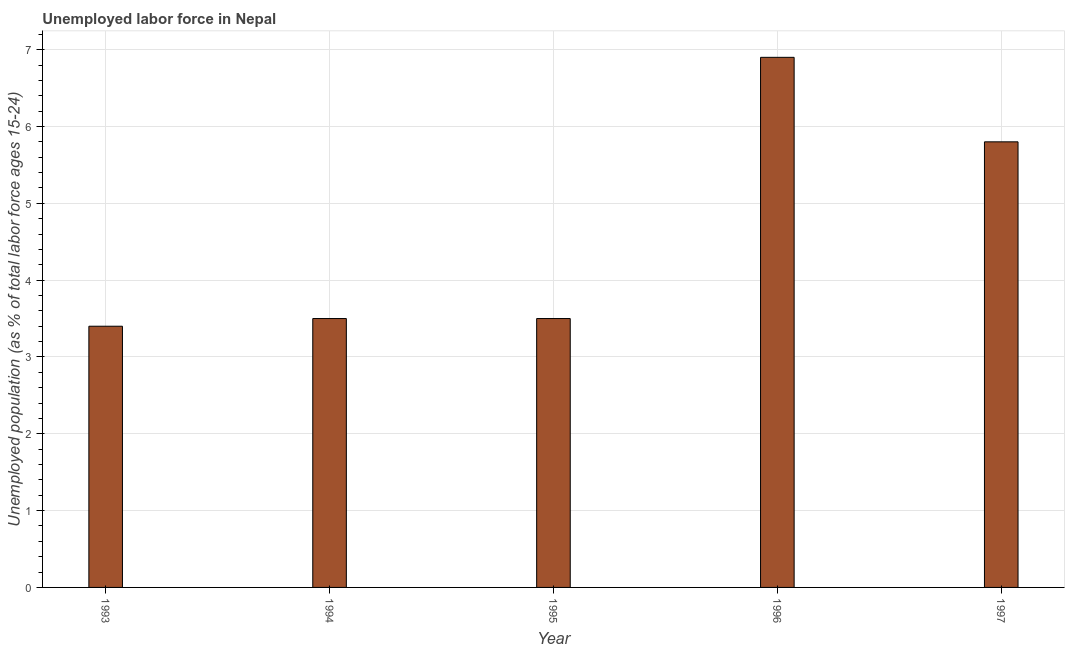Does the graph contain any zero values?
Keep it short and to the point. No. What is the title of the graph?
Your answer should be compact. Unemployed labor force in Nepal. What is the label or title of the X-axis?
Your response must be concise. Year. What is the label or title of the Y-axis?
Your response must be concise. Unemployed population (as % of total labor force ages 15-24). Across all years, what is the maximum total unemployed youth population?
Keep it short and to the point. 6.9. Across all years, what is the minimum total unemployed youth population?
Offer a terse response. 3.4. What is the sum of the total unemployed youth population?
Provide a short and direct response. 23.1. What is the difference between the total unemployed youth population in 1995 and 1996?
Your response must be concise. -3.4. What is the average total unemployed youth population per year?
Your answer should be compact. 4.62. What is the median total unemployed youth population?
Your response must be concise. 3.5. In how many years, is the total unemployed youth population greater than 6.6 %?
Provide a succinct answer. 1. Do a majority of the years between 1993 and 1995 (inclusive) have total unemployed youth population greater than 5.6 %?
Your answer should be compact. No. What is the ratio of the total unemployed youth population in 1993 to that in 1995?
Your response must be concise. 0.97. Is the total unemployed youth population in 1993 less than that in 1995?
Provide a succinct answer. Yes. Is the difference between the total unemployed youth population in 1995 and 1996 greater than the difference between any two years?
Give a very brief answer. No. How many bars are there?
Offer a terse response. 5. How many years are there in the graph?
Offer a very short reply. 5. What is the difference between two consecutive major ticks on the Y-axis?
Your answer should be very brief. 1. Are the values on the major ticks of Y-axis written in scientific E-notation?
Offer a very short reply. No. What is the Unemployed population (as % of total labor force ages 15-24) in 1993?
Offer a very short reply. 3.4. What is the Unemployed population (as % of total labor force ages 15-24) in 1996?
Offer a very short reply. 6.9. What is the Unemployed population (as % of total labor force ages 15-24) in 1997?
Your answer should be very brief. 5.8. What is the difference between the Unemployed population (as % of total labor force ages 15-24) in 1994 and 1996?
Provide a succinct answer. -3.4. What is the difference between the Unemployed population (as % of total labor force ages 15-24) in 1994 and 1997?
Ensure brevity in your answer.  -2.3. What is the difference between the Unemployed population (as % of total labor force ages 15-24) in 1995 and 1997?
Give a very brief answer. -2.3. What is the difference between the Unemployed population (as % of total labor force ages 15-24) in 1996 and 1997?
Your answer should be compact. 1.1. What is the ratio of the Unemployed population (as % of total labor force ages 15-24) in 1993 to that in 1994?
Offer a very short reply. 0.97. What is the ratio of the Unemployed population (as % of total labor force ages 15-24) in 1993 to that in 1996?
Your answer should be very brief. 0.49. What is the ratio of the Unemployed population (as % of total labor force ages 15-24) in 1993 to that in 1997?
Provide a succinct answer. 0.59. What is the ratio of the Unemployed population (as % of total labor force ages 15-24) in 1994 to that in 1996?
Provide a succinct answer. 0.51. What is the ratio of the Unemployed population (as % of total labor force ages 15-24) in 1994 to that in 1997?
Your response must be concise. 0.6. What is the ratio of the Unemployed population (as % of total labor force ages 15-24) in 1995 to that in 1996?
Offer a very short reply. 0.51. What is the ratio of the Unemployed population (as % of total labor force ages 15-24) in 1995 to that in 1997?
Offer a terse response. 0.6. What is the ratio of the Unemployed population (as % of total labor force ages 15-24) in 1996 to that in 1997?
Make the answer very short. 1.19. 